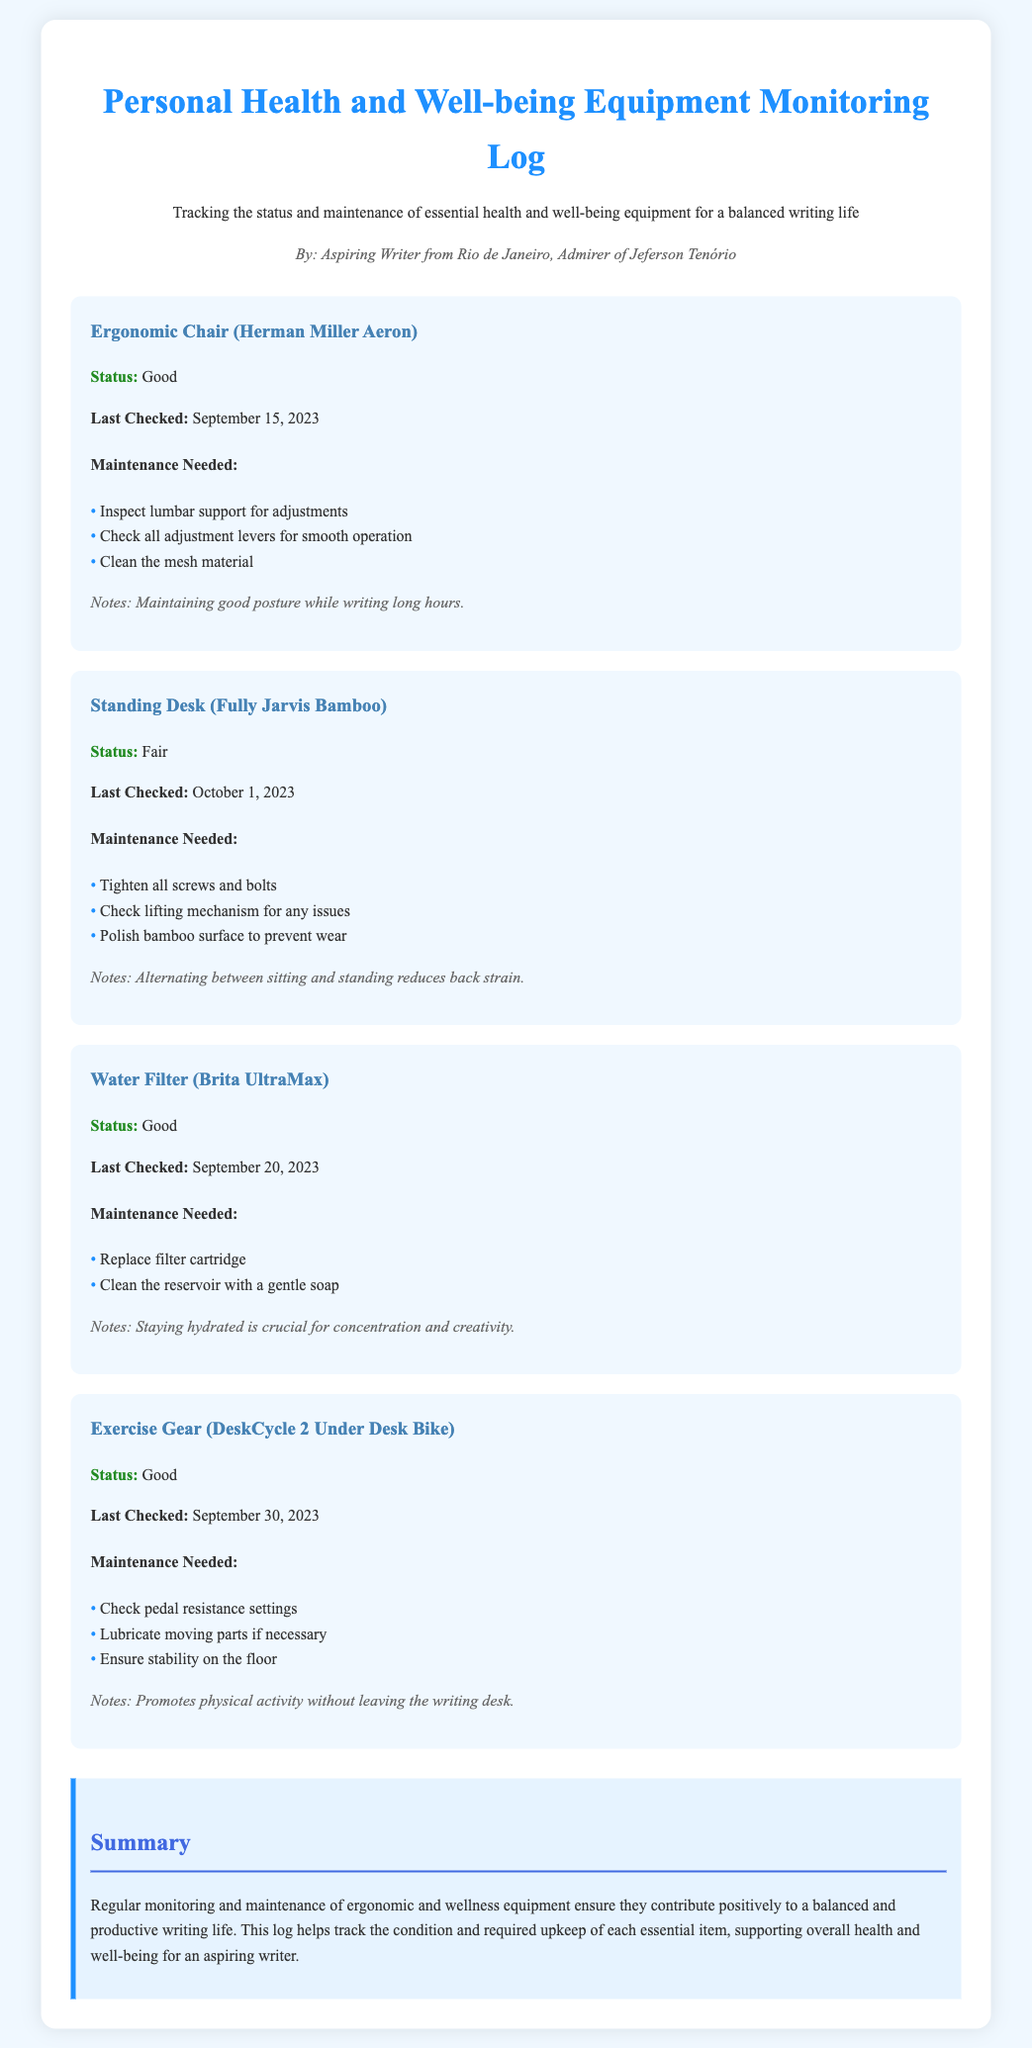What is the status of the Ergonomic Chair? The status of the Ergonomic Chair is mentioned in the document as "Good."
Answer: Good When was the Standing Desk last checked? The document provides the date when the Standing Desk was last checked, which is October 1, 2023.
Answer: October 1, 2023 What maintenance is needed for the Water Filter? The maintenance required for the Water Filter is listed in the document, including replacing the filter cartridge and cleaning the reservoir.
Answer: Replace filter cartridge, clean the reservoir What is the status of the Exercise Gear? The status of the Exercise Gear is indicated as "Good."
Answer: Good What notes are associated with the Standing Desk? Notes regarding the Standing Desk are provided, emphasizing the benefits of alternating between sitting and standing.
Answer: Alternating between sitting and standing reduces back strain How many maintenance tasks are listed for the Ergonomic Chair? The document lists the number of maintenance tasks to be performed on the Ergonomic Chair, which are three in total.
Answer: 3 What type of document is this? The document is specifically a monitoring log for personal health and well-being equipment.
Answer: Maintenance log What is stated about the importance of hydration? The document notes that staying hydrated is crucial for concentration and creativity.
Answer: Staying hydrated is crucial for concentration and creativity 